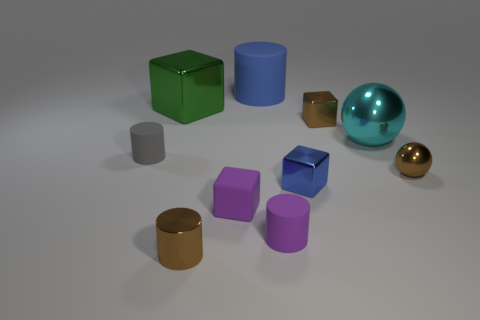What number of other things are there of the same shape as the tiny gray rubber thing?
Make the answer very short. 3. Are there any cyan shiny spheres on the right side of the brown thing that is left of the large matte object?
Give a very brief answer. Yes. How many rubber objects are either green things or small cyan spheres?
Your answer should be very brief. 0. There is a cube that is behind the small blue cube and in front of the green metal thing; what is it made of?
Give a very brief answer. Metal. There is a tiny brown thing that is behind the tiny rubber cylinder behind the purple cube; is there a brown shiny cylinder that is left of it?
Your answer should be compact. Yes. What shape is the small gray thing that is made of the same material as the large cylinder?
Your response must be concise. Cylinder. Is the number of green metallic objects that are right of the small sphere less than the number of large blue cylinders that are right of the green thing?
Your response must be concise. Yes. What number of large things are either brown shiny blocks or rubber blocks?
Provide a short and direct response. 0. There is a brown object behind the gray matte cylinder; is its shape the same as the big shiny thing on the left side of the large ball?
Ensure brevity in your answer.  Yes. How big is the green metallic thing that is on the right side of the tiny matte cylinder behind the small matte cylinder right of the tiny gray matte thing?
Make the answer very short. Large. 